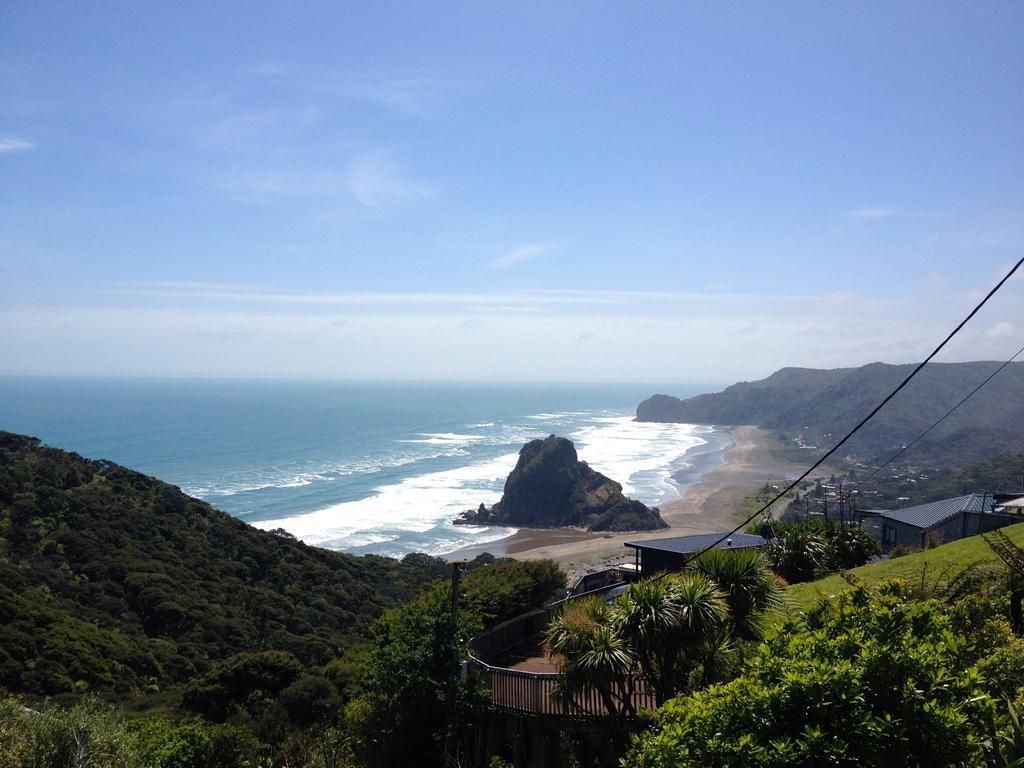Describe this image in one or two sentences. In this image we can see some mountains, there are some trees, houses and in the background of the image there is water and clear sky. 